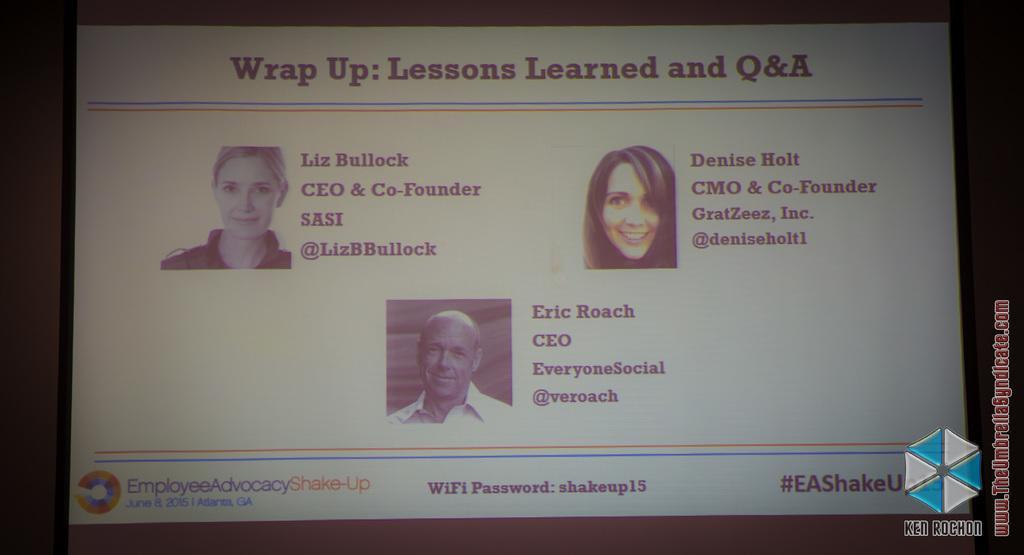Please provide a concise description of this image. In this image there is a screen. In the screen we can see pictures of three people and there is text. 